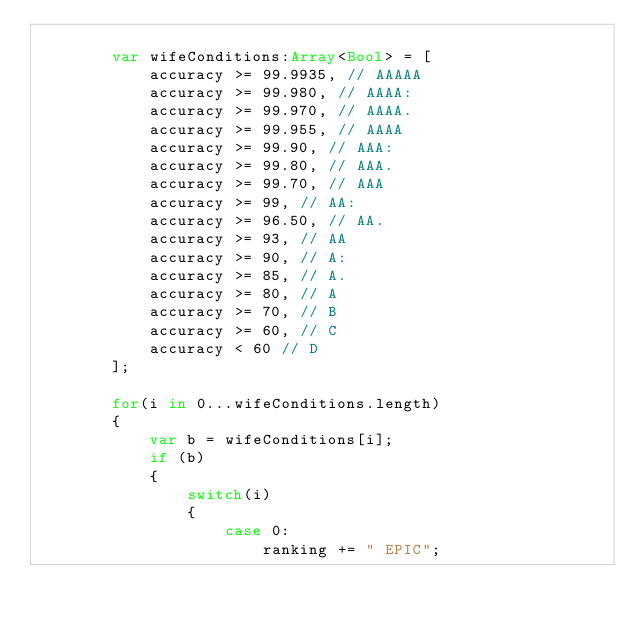<code> <loc_0><loc_0><loc_500><loc_500><_Haxe_>
        var wifeConditions:Array<Bool> = [
            accuracy >= 99.9935, // AAAAA
            accuracy >= 99.980, // AAAA:
            accuracy >= 99.970, // AAAA.
            accuracy >= 99.955, // AAAA
            accuracy >= 99.90, // AAA:
            accuracy >= 99.80, // AAA.
            accuracy >= 99.70, // AAA
            accuracy >= 99, // AA:
            accuracy >= 96.50, // AA.
            accuracy >= 93, // AA
            accuracy >= 90, // A:
            accuracy >= 85, // A.
            accuracy >= 80, // A
            accuracy >= 70, // B
            accuracy >= 60, // C
            accuracy < 60 // D
        ];

        for(i in 0...wifeConditions.length)
        {
            var b = wifeConditions[i];
            if (b)
            {
                switch(i)
                {
                    case 0:
                        ranking += " EPIC";</code> 